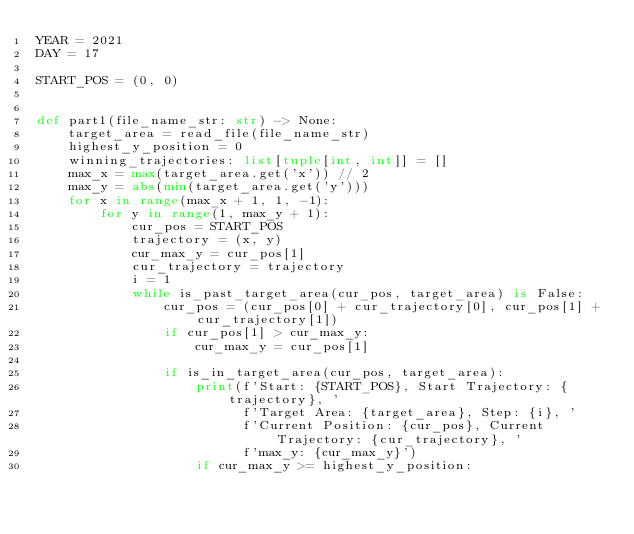<code> <loc_0><loc_0><loc_500><loc_500><_Python_>YEAR = 2021
DAY = 17

START_POS = (0, 0)


def part1(file_name_str: str) -> None:
    target_area = read_file(file_name_str)
    highest_y_position = 0
    winning_trajectories: list[tuple[int, int]] = []
    max_x = max(target_area.get('x')) // 2
    max_y = abs(min(target_area.get('y')))
    for x in range(max_x + 1, 1, -1):
        for y in range(1, max_y + 1):
            cur_pos = START_POS
            trajectory = (x, y)
            cur_max_y = cur_pos[1]
            cur_trajectory = trajectory
            i = 1
            while is_past_target_area(cur_pos, target_area) is False:
                cur_pos = (cur_pos[0] + cur_trajectory[0], cur_pos[1] + cur_trajectory[1])
                if cur_pos[1] > cur_max_y:
                    cur_max_y = cur_pos[1]

                if is_in_target_area(cur_pos, target_area):
                    print(f'Start: {START_POS}, Start Trajectory: {trajectory}, '
                          f'Target Area: {target_area}, Step: {i}, '
                          f'Current Position: {cur_pos}, Current Trajectory: {cur_trajectory}, '
                          f'max_y: {cur_max_y}')
                    if cur_max_y >= highest_y_position:</code> 